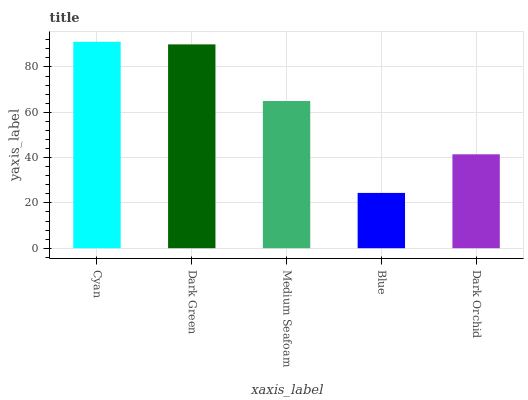Is Blue the minimum?
Answer yes or no. Yes. Is Cyan the maximum?
Answer yes or no. Yes. Is Dark Green the minimum?
Answer yes or no. No. Is Dark Green the maximum?
Answer yes or no. No. Is Cyan greater than Dark Green?
Answer yes or no. Yes. Is Dark Green less than Cyan?
Answer yes or no. Yes. Is Dark Green greater than Cyan?
Answer yes or no. No. Is Cyan less than Dark Green?
Answer yes or no. No. Is Medium Seafoam the high median?
Answer yes or no. Yes. Is Medium Seafoam the low median?
Answer yes or no. Yes. Is Blue the high median?
Answer yes or no. No. Is Dark Orchid the low median?
Answer yes or no. No. 